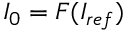<formula> <loc_0><loc_0><loc_500><loc_500>I _ { 0 } = F ( I _ { r e f } )</formula> 